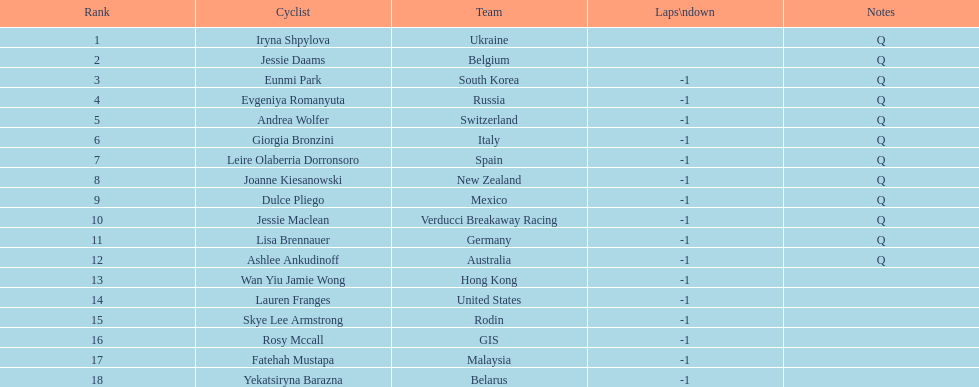What team is listed previous to belgium? Ukraine. 